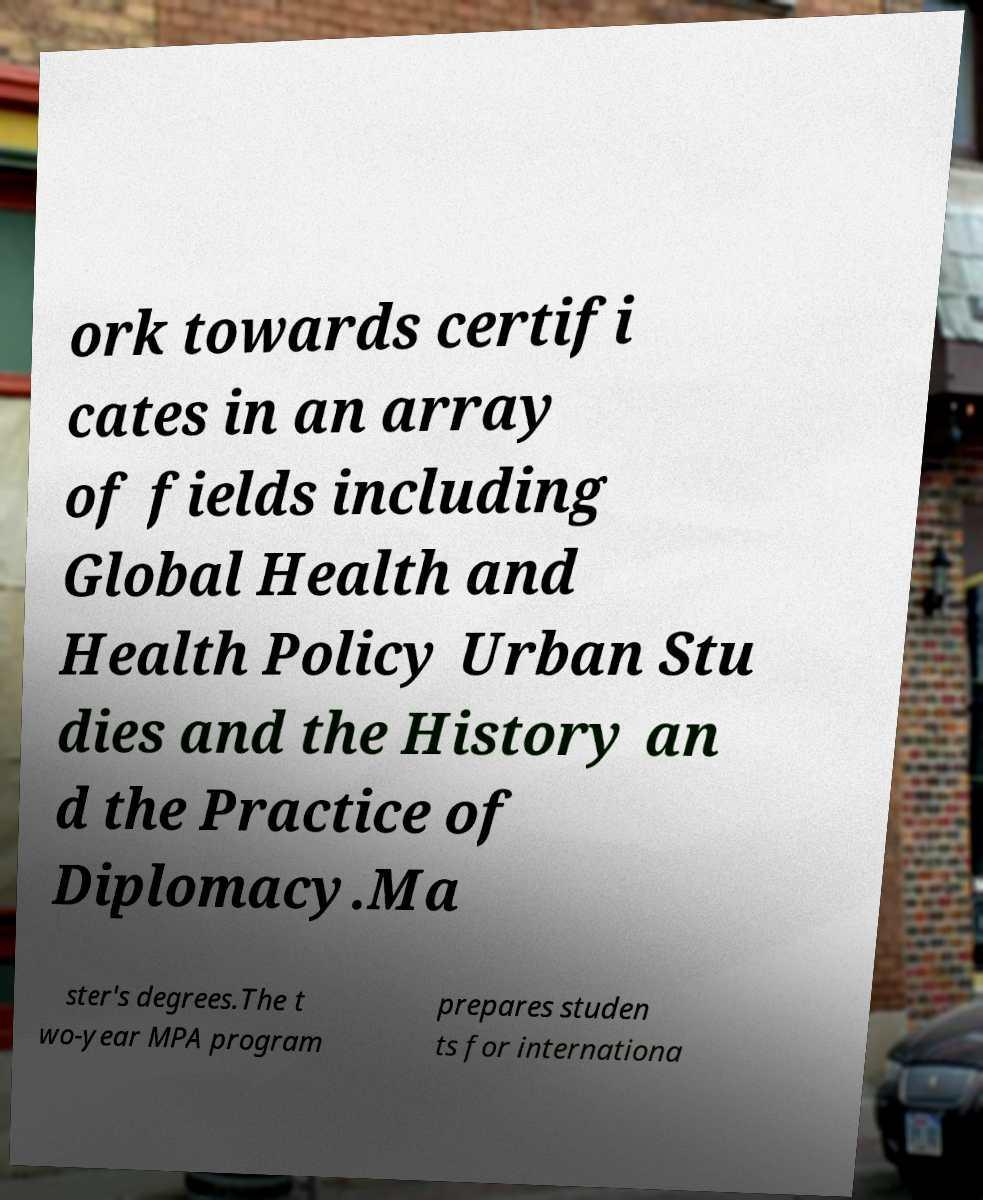Can you accurately transcribe the text from the provided image for me? ork towards certifi cates in an array of fields including Global Health and Health Policy Urban Stu dies and the History an d the Practice of Diplomacy.Ma ster's degrees.The t wo-year MPA program prepares studen ts for internationa 